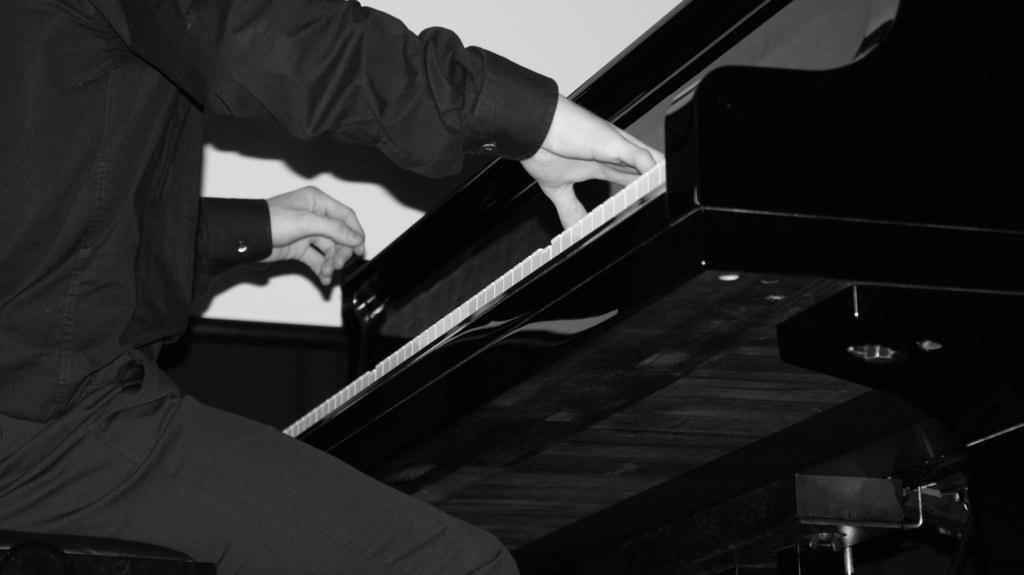Who is the main subject in the image? There is a person in the image. What is the person doing in the image? The person is sitting and playing a piano. What book is the person reading in the image? There is no book present in the image, and the person is playing a piano, not reading. 